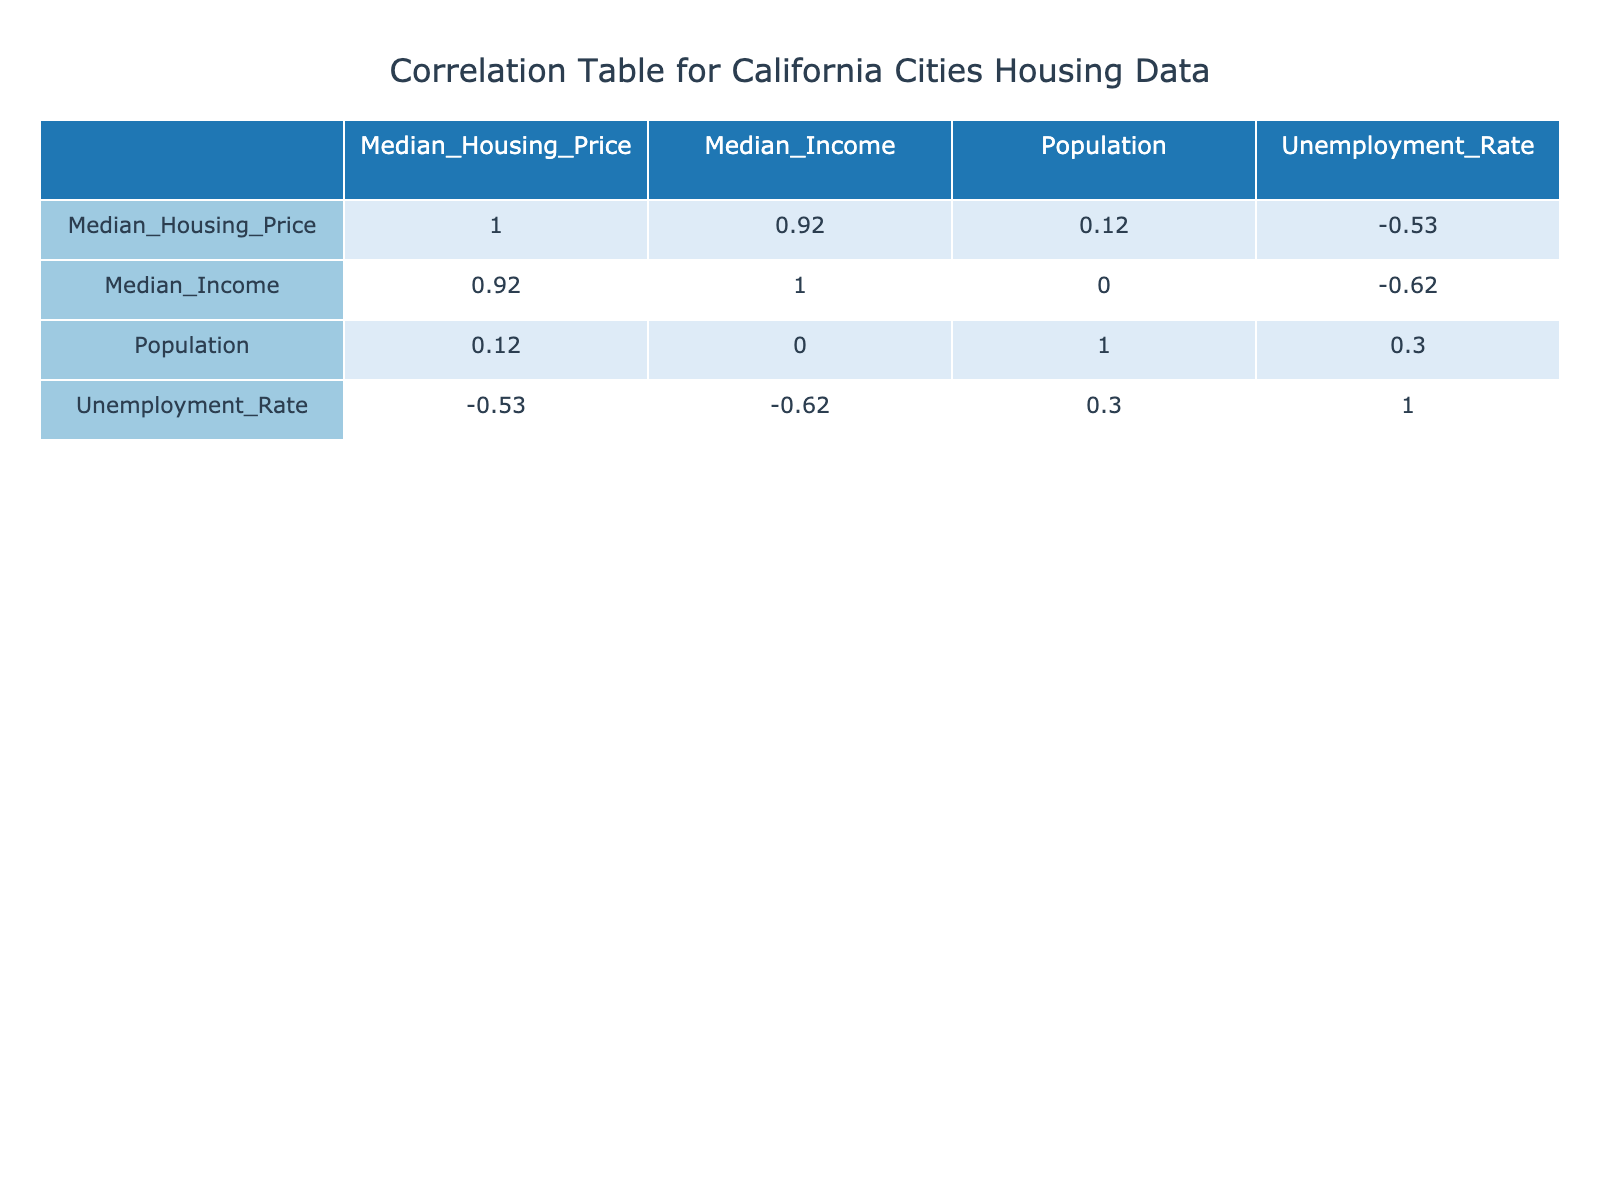What is the median housing price in San Francisco? According to the table, the median housing price for San Francisco is listed clearly in the row for San Francisco.
Answer: 1500000 What is the median income for Sacramento? The row for Sacramento specifies that the median income is found directly in the corresponding column.
Answer: 60000 Which city has the highest median income? By examining each city's median income in the table, we see that San Jose has the highest median income at 130000.
Answer: San Jose What is the difference in median housing prices between Los Angeles and Fresno? The median housing price for Los Angeles is 850000 and for Fresno, it is 350000. The difference is calculated as 850000 - 350000, which equals 500000.
Answer: 500000 Is the unemployment rate in Irvine lower than that of San Francisco? Looking at the unemployment rates in the table, Irvine has a rate of 2.7, while San Francisco has 3.1. Since 2.7 is less than 3.1, this statement is true.
Answer: Yes What is the average median income of all cities listed? First, we sum the median incomes: 120000 + 80000 + 85000 + 60000 + 130000 + 50000 + 72000 + 100000 + 65000 + 120000 = 1000000. There are 10 cities, so we divide the total by 10: 1000000 / 10 = 100000.
Answer: 100000 Are there more people living in San Diego than in Sacramento? According to the table, San Diego has a population of 1423851 while Sacramento has 513624. Since 1423851 is greater than 513624, the answer is yes.
Answer: Yes What is the median housing price of the city with the lowest unemployment rate? Looking for the lowest unemployment rate, we find Irvine at 2.7. The median housing price for Irvine is 950000, which directly answers this question.
Answer: 950000 What is the relationship between median housing price and median income? The correlation can be assessed from the correlation matrix in the table. A positive correlation indicates that generally, as income increases, so do housing prices. The specific correlation value can be evaluated by finding the entry in the correlation matrix for these two variables.
Answer: Positive correlation 